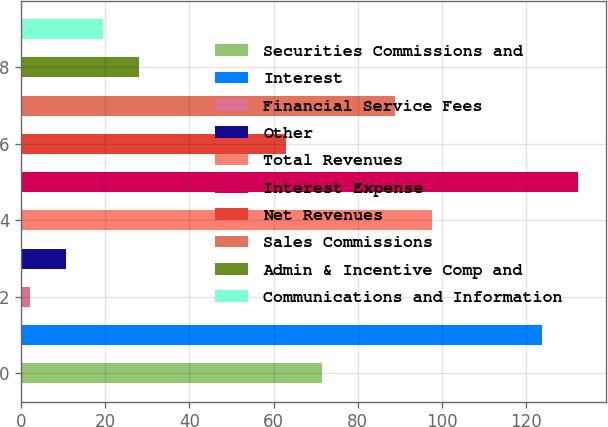Convert chart. <chart><loc_0><loc_0><loc_500><loc_500><bar_chart><fcel>Securities Commissions and<fcel>Interest<fcel>Financial Service Fees<fcel>Other<fcel>Total Revenues<fcel>Interest Expense<fcel>Net Revenues<fcel>Sales Commissions<fcel>Admin & Incentive Comp and<fcel>Communications and Information<nl><fcel>71.6<fcel>123.8<fcel>2<fcel>10.7<fcel>97.7<fcel>132.5<fcel>62.9<fcel>89<fcel>28.1<fcel>19.4<nl></chart> 